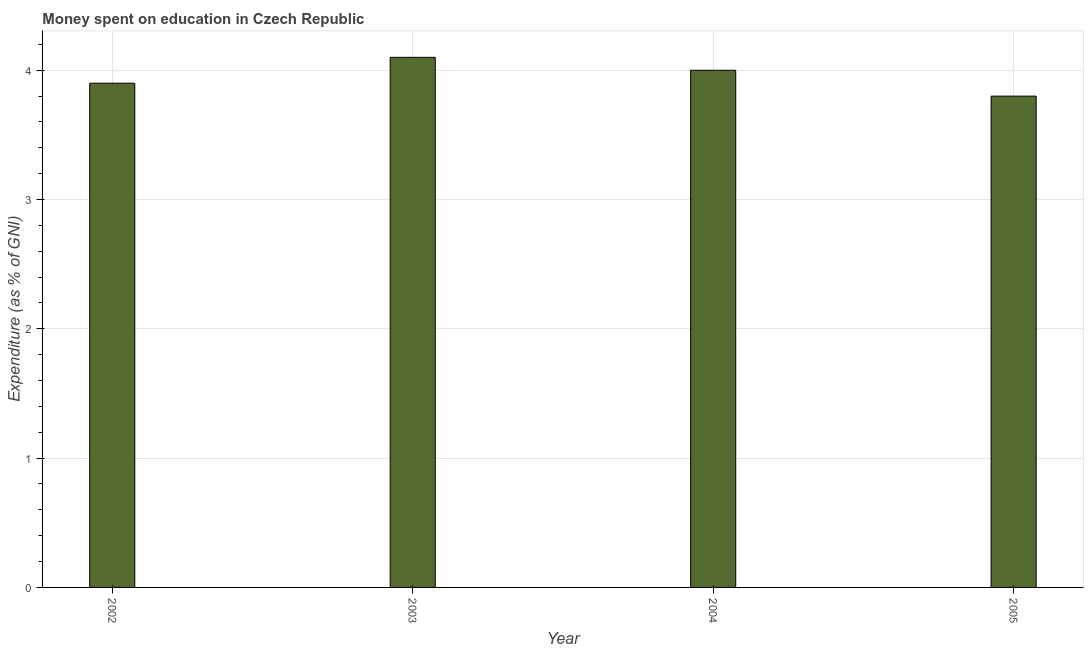Does the graph contain any zero values?
Ensure brevity in your answer.  No. Does the graph contain grids?
Your answer should be very brief. Yes. What is the title of the graph?
Ensure brevity in your answer.  Money spent on education in Czech Republic. What is the label or title of the Y-axis?
Offer a very short reply. Expenditure (as % of GNI). What is the expenditure on education in 2004?
Your response must be concise. 4. In which year was the expenditure on education maximum?
Give a very brief answer. 2003. In which year was the expenditure on education minimum?
Keep it short and to the point. 2005. What is the difference between the expenditure on education in 2002 and 2003?
Offer a very short reply. -0.2. What is the average expenditure on education per year?
Offer a terse response. 3.95. What is the median expenditure on education?
Ensure brevity in your answer.  3.95. In how many years, is the expenditure on education greater than 3.6 %?
Your answer should be compact. 4. What is the ratio of the expenditure on education in 2002 to that in 2003?
Ensure brevity in your answer.  0.95. What is the difference between the highest and the second highest expenditure on education?
Offer a very short reply. 0.1. Are all the bars in the graph horizontal?
Your response must be concise. No. How many years are there in the graph?
Keep it short and to the point. 4. What is the Expenditure (as % of GNI) in 2002?
Your answer should be very brief. 3.9. What is the Expenditure (as % of GNI) in 2003?
Offer a very short reply. 4.1. What is the Expenditure (as % of GNI) in 2004?
Make the answer very short. 4. What is the Expenditure (as % of GNI) of 2005?
Give a very brief answer. 3.8. What is the difference between the Expenditure (as % of GNI) in 2002 and 2003?
Your answer should be very brief. -0.2. What is the difference between the Expenditure (as % of GNI) in 2002 and 2004?
Ensure brevity in your answer.  -0.1. What is the ratio of the Expenditure (as % of GNI) in 2002 to that in 2003?
Provide a short and direct response. 0.95. What is the ratio of the Expenditure (as % of GNI) in 2002 to that in 2004?
Provide a succinct answer. 0.97. What is the ratio of the Expenditure (as % of GNI) in 2003 to that in 2004?
Offer a terse response. 1.02. What is the ratio of the Expenditure (as % of GNI) in 2003 to that in 2005?
Your response must be concise. 1.08. What is the ratio of the Expenditure (as % of GNI) in 2004 to that in 2005?
Your answer should be compact. 1.05. 